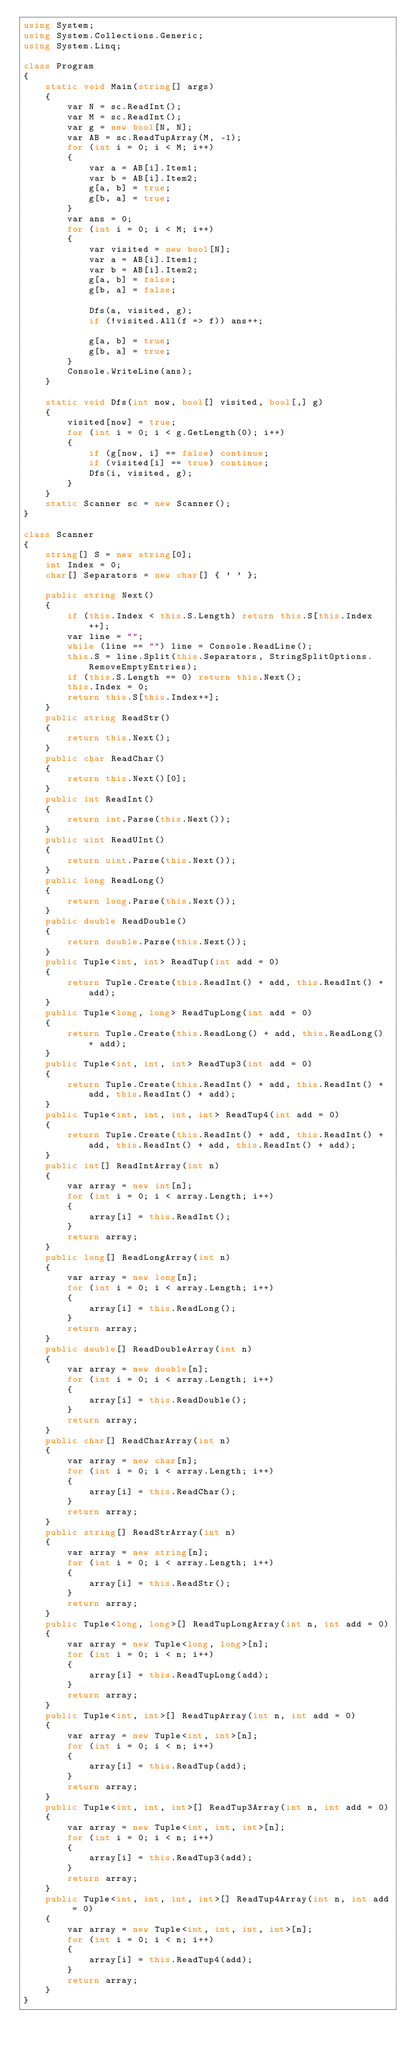Convert code to text. <code><loc_0><loc_0><loc_500><loc_500><_C#_>using System;
using System.Collections.Generic;
using System.Linq;

class Program
{
    static void Main(string[] args)
    {
        var N = sc.ReadInt();
        var M = sc.ReadInt();
        var g = new bool[N, N];
        var AB = sc.ReadTupArray(M, -1);
        for (int i = 0; i < M; i++)
        {
            var a = AB[i].Item1;
            var b = AB[i].Item2;
            g[a, b] = true;
            g[b, a] = true;
        }
        var ans = 0;
        for (int i = 0; i < M; i++)
        {
            var visited = new bool[N];
            var a = AB[i].Item1;
            var b = AB[i].Item2;
            g[a, b] = false;
            g[b, a] = false;

            Dfs(a, visited, g);
            if (!visited.All(f => f)) ans++;

            g[a, b] = true;
            g[b, a] = true;
        }
        Console.WriteLine(ans);
    }

    static void Dfs(int now, bool[] visited, bool[,] g)
    {
        visited[now] = true;
        for (int i = 0; i < g.GetLength(0); i++)
        {
            if (g[now, i] == false) continue;
            if (visited[i] == true) continue;
            Dfs(i, visited, g);
        }
    }
    static Scanner sc = new Scanner();
}

class Scanner
{
    string[] S = new string[0];
    int Index = 0;
    char[] Separators = new char[] { ' ' };

    public string Next()
    {
        if (this.Index < this.S.Length) return this.S[this.Index++];
        var line = "";
        while (line == "") line = Console.ReadLine();
        this.S = line.Split(this.Separators, StringSplitOptions.RemoveEmptyEntries);
        if (this.S.Length == 0) return this.Next();
        this.Index = 0;
        return this.S[this.Index++];
    }
    public string ReadStr()
    {
        return this.Next();
    }
    public char ReadChar()
    {
        return this.Next()[0];
    }
    public int ReadInt()
    {
        return int.Parse(this.Next());
    }
    public uint ReadUInt()
    {
        return uint.Parse(this.Next());
    }
    public long ReadLong()
    {
        return long.Parse(this.Next());
    }
    public double ReadDouble()
    {
        return double.Parse(this.Next());
    }
    public Tuple<int, int> ReadTup(int add = 0)
    {
        return Tuple.Create(this.ReadInt() + add, this.ReadInt() + add);
    }
    public Tuple<long, long> ReadTupLong(int add = 0)
    {
        return Tuple.Create(this.ReadLong() + add, this.ReadLong() + add);
    }
    public Tuple<int, int, int> ReadTup3(int add = 0)
    {
        return Tuple.Create(this.ReadInt() + add, this.ReadInt() + add, this.ReadInt() + add);
    }
    public Tuple<int, int, int, int> ReadTup4(int add = 0)
    {
        return Tuple.Create(this.ReadInt() + add, this.ReadInt() + add, this.ReadInt() + add, this.ReadInt() + add);
    }
    public int[] ReadIntArray(int n)
    {
        var array = new int[n];
        for (int i = 0; i < array.Length; i++)
        {
            array[i] = this.ReadInt();
        }
        return array;
    }
    public long[] ReadLongArray(int n)
    {
        var array = new long[n];
        for (int i = 0; i < array.Length; i++)
        {
            array[i] = this.ReadLong();
        }
        return array;
    }
    public double[] ReadDoubleArray(int n)
    {
        var array = new double[n];
        for (int i = 0; i < array.Length; i++)
        {
            array[i] = this.ReadDouble();
        }
        return array;
    }
    public char[] ReadCharArray(int n)
    {
        var array = new char[n];
        for (int i = 0; i < array.Length; i++)
        {
            array[i] = this.ReadChar();
        }
        return array;
    }
    public string[] ReadStrArray(int n)
    {
        var array = new string[n];
        for (int i = 0; i < array.Length; i++)
        {
            array[i] = this.ReadStr();
        }
        return array;
    }
    public Tuple<long, long>[] ReadTupLongArray(int n, int add = 0)
    {
        var array = new Tuple<long, long>[n];
        for (int i = 0; i < n; i++)
        {
            array[i] = this.ReadTupLong(add);
        }
        return array;
    }
    public Tuple<int, int>[] ReadTupArray(int n, int add = 0)
    {
        var array = new Tuple<int, int>[n];
        for (int i = 0; i < n; i++)
        {
            array[i] = this.ReadTup(add);
        }
        return array;
    }
    public Tuple<int, int, int>[] ReadTup3Array(int n, int add = 0)
    {
        var array = new Tuple<int, int, int>[n];
        for (int i = 0; i < n; i++)
        {
            array[i] = this.ReadTup3(add);
        }
        return array;
    }
    public Tuple<int, int, int, int>[] ReadTup4Array(int n, int add = 0)
    {
        var array = new Tuple<int, int, int, int>[n];
        for (int i = 0; i < n; i++)
        {
            array[i] = this.ReadTup4(add);
        }
        return array;
    }
}
</code> 